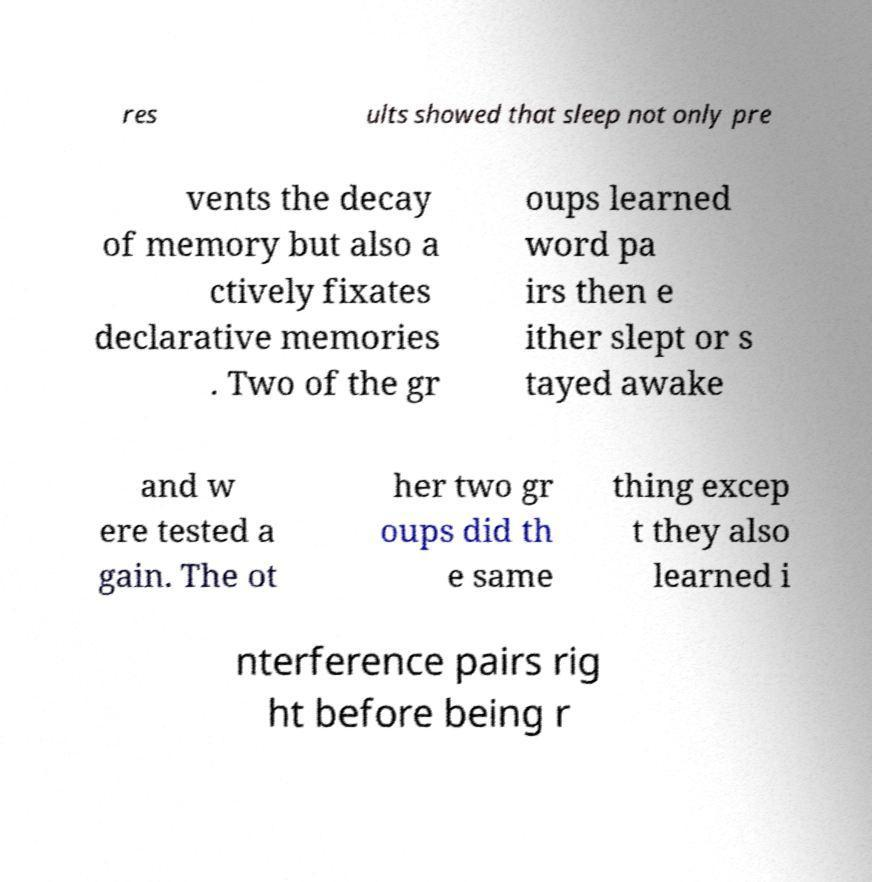There's text embedded in this image that I need extracted. Can you transcribe it verbatim? res ults showed that sleep not only pre vents the decay of memory but also a ctively fixates declarative memories . Two of the gr oups learned word pa irs then e ither slept or s tayed awake and w ere tested a gain. The ot her two gr oups did th e same thing excep t they also learned i nterference pairs rig ht before being r 